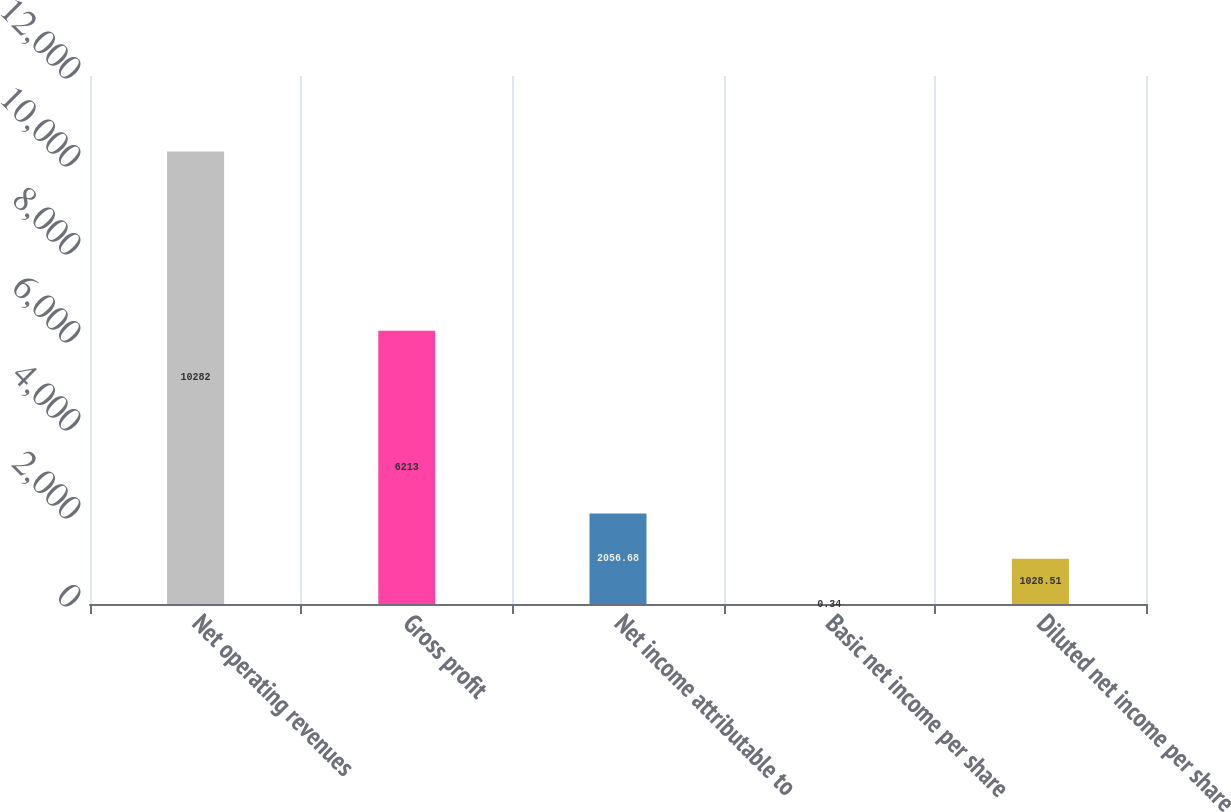<chart> <loc_0><loc_0><loc_500><loc_500><bar_chart><fcel>Net operating revenues<fcel>Gross profit<fcel>Net income attributable to<fcel>Basic net income per share<fcel>Diluted net income per share<nl><fcel>10282<fcel>6213<fcel>2056.68<fcel>0.34<fcel>1028.51<nl></chart> 